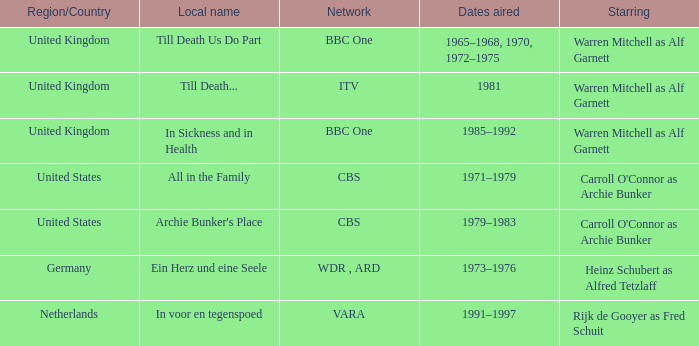Who was the star for the Vara network? Rijk de Gooyer as Fred Schuit. 